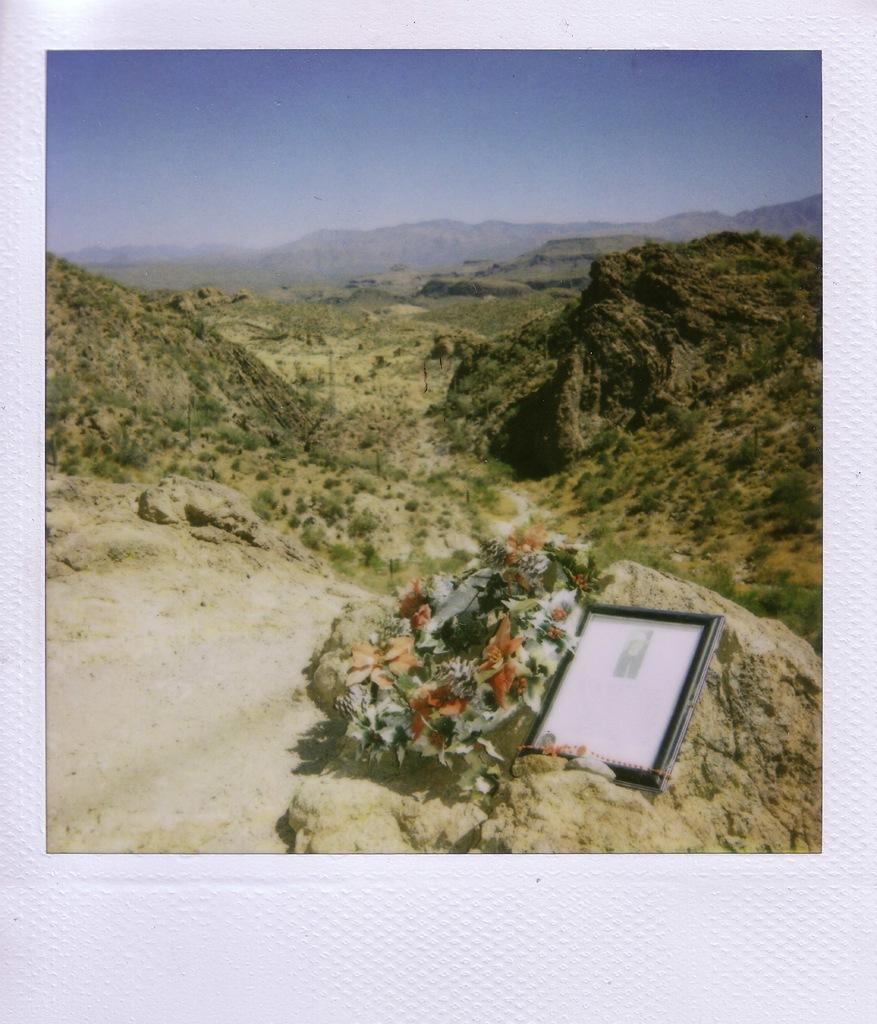What is the main object in the image? There is a board in the image. What type of natural environment is depicted in the image? There are trees and mountains in the image. What is visible in the background of the image? The sky is visible in the image. What type of wine is being served on the cushion in the image? There is no wine or cushion present in the image; it features a board, trees, mountains, and the sky. 